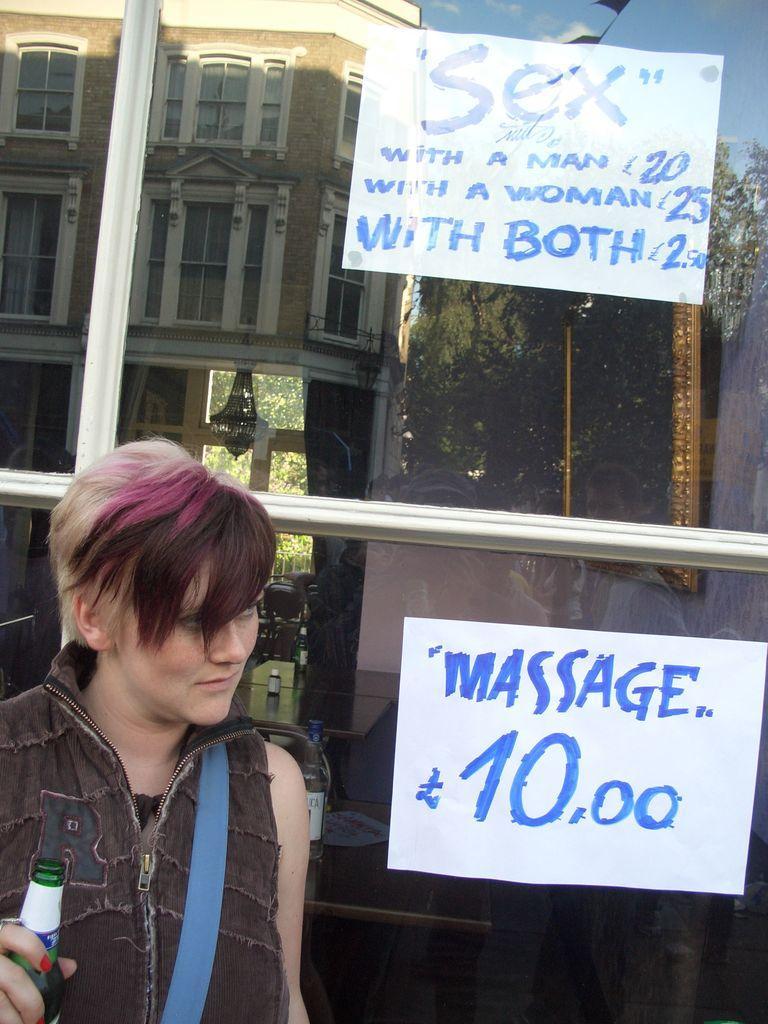In one or two sentences, can you explain what this image depicts? In this image there is a woman wearing a jacket carrying a backpack and holding a bottle in her hand and at the backside of the image there is a glass door and some name boards 